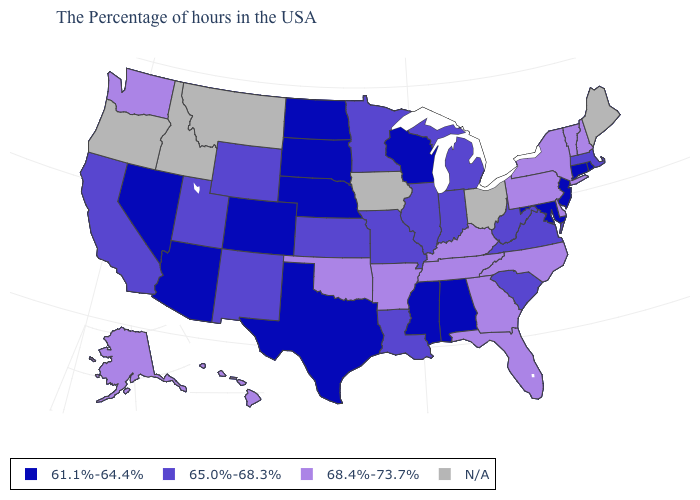How many symbols are there in the legend?
Short answer required. 4. Which states have the lowest value in the USA?
Be succinct. Rhode Island, Connecticut, New Jersey, Maryland, Alabama, Wisconsin, Mississippi, Nebraska, Texas, South Dakota, North Dakota, Colorado, Arizona, Nevada. What is the highest value in the USA?
Give a very brief answer. 68.4%-73.7%. What is the value of Idaho?
Be succinct. N/A. What is the value of Rhode Island?
Concise answer only. 61.1%-64.4%. Name the states that have a value in the range 68.4%-73.7%?
Keep it brief. New Hampshire, Vermont, New York, Delaware, Pennsylvania, North Carolina, Florida, Georgia, Kentucky, Tennessee, Arkansas, Oklahoma, Washington, Alaska, Hawaii. Does Arizona have the highest value in the West?
Be succinct. No. Which states have the lowest value in the USA?
Give a very brief answer. Rhode Island, Connecticut, New Jersey, Maryland, Alabama, Wisconsin, Mississippi, Nebraska, Texas, South Dakota, North Dakota, Colorado, Arizona, Nevada. What is the value of Kentucky?
Short answer required. 68.4%-73.7%. What is the lowest value in states that border Texas?
Be succinct. 65.0%-68.3%. Which states hav the highest value in the MidWest?
Be succinct. Michigan, Indiana, Illinois, Missouri, Minnesota, Kansas. What is the lowest value in the West?
Answer briefly. 61.1%-64.4%. Which states have the lowest value in the West?
Answer briefly. Colorado, Arizona, Nevada. Which states have the lowest value in the USA?
Answer briefly. Rhode Island, Connecticut, New Jersey, Maryland, Alabama, Wisconsin, Mississippi, Nebraska, Texas, South Dakota, North Dakota, Colorado, Arizona, Nevada. 